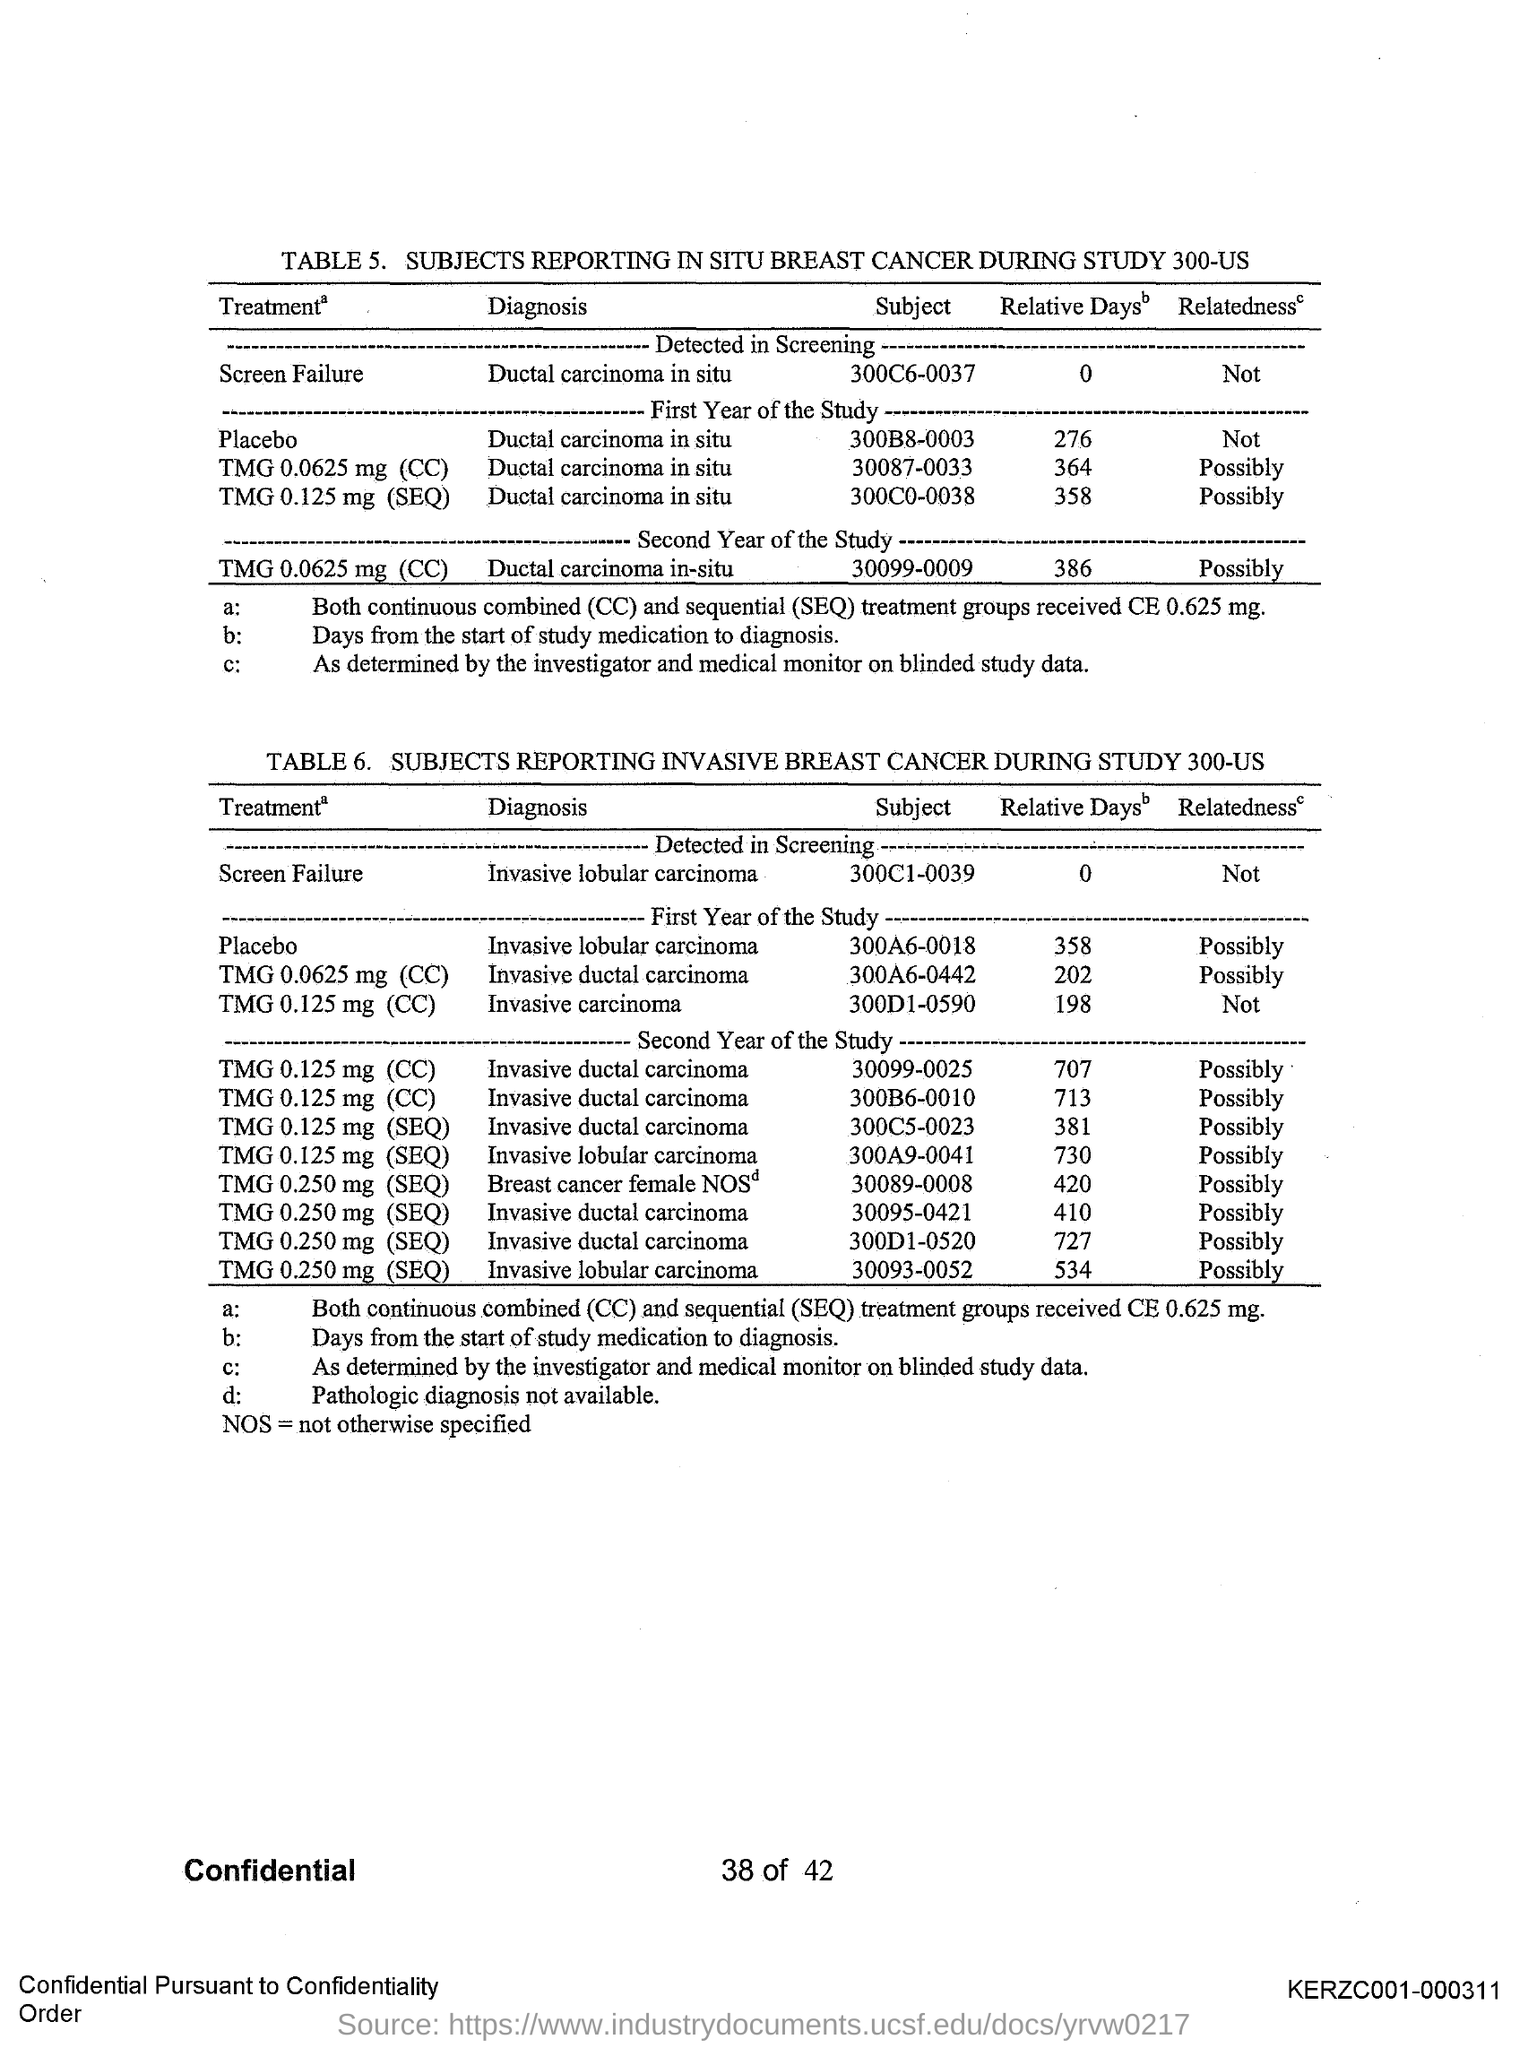Specify some key components in this picture. The page number is 38 out of 42. The document number is KERZC001-000311. 